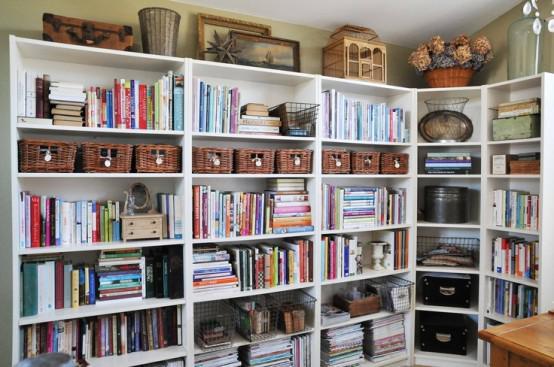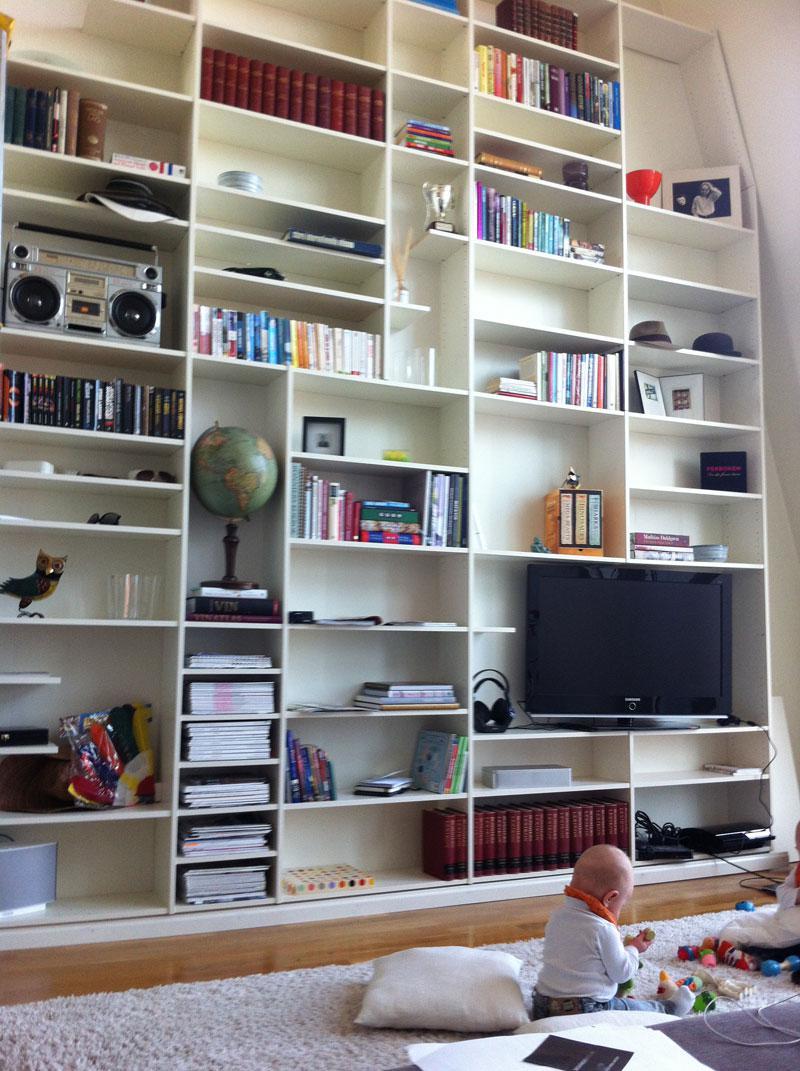The first image is the image on the left, the second image is the image on the right. Examine the images to the left and right. Is the description "Seating furniture is visible in front of a bookcase in one image." accurate? Answer yes or no. No. The first image is the image on the left, the second image is the image on the right. Considering the images on both sides, is "A chair is near a book shelf." valid? Answer yes or no. No. 